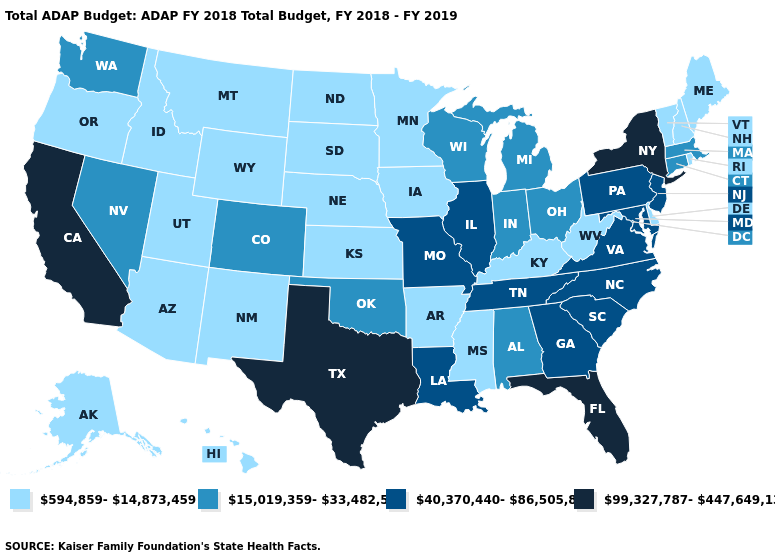What is the value of Nevada?
Write a very short answer. 15,019,359-33,482,585. What is the value of South Dakota?
Answer briefly. 594,859-14,873,459. What is the value of Oklahoma?
Answer briefly. 15,019,359-33,482,585. Name the states that have a value in the range 99,327,787-447,649,130?
Give a very brief answer. California, Florida, New York, Texas. Among the states that border Iowa , does Illinois have the highest value?
Be succinct. Yes. What is the lowest value in states that border Kentucky?
Concise answer only. 594,859-14,873,459. Name the states that have a value in the range 594,859-14,873,459?
Concise answer only. Alaska, Arizona, Arkansas, Delaware, Hawaii, Idaho, Iowa, Kansas, Kentucky, Maine, Minnesota, Mississippi, Montana, Nebraska, New Hampshire, New Mexico, North Dakota, Oregon, Rhode Island, South Dakota, Utah, Vermont, West Virginia, Wyoming. Does Missouri have a lower value than Texas?
Keep it brief. Yes. Among the states that border West Virginia , which have the highest value?
Write a very short answer. Maryland, Pennsylvania, Virginia. What is the value of Iowa?
Answer briefly. 594,859-14,873,459. Which states have the lowest value in the USA?
Answer briefly. Alaska, Arizona, Arkansas, Delaware, Hawaii, Idaho, Iowa, Kansas, Kentucky, Maine, Minnesota, Mississippi, Montana, Nebraska, New Hampshire, New Mexico, North Dakota, Oregon, Rhode Island, South Dakota, Utah, Vermont, West Virginia, Wyoming. Among the states that border Missouri , which have the highest value?
Concise answer only. Illinois, Tennessee. What is the lowest value in the USA?
Concise answer only. 594,859-14,873,459. Does Texas have the highest value in the USA?
Write a very short answer. Yes. What is the value of Florida?
Be succinct. 99,327,787-447,649,130. 